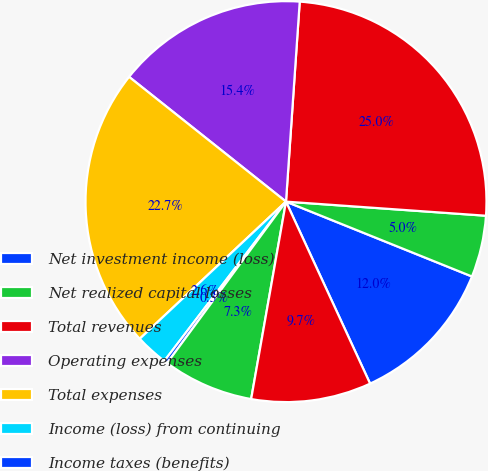<chart> <loc_0><loc_0><loc_500><loc_500><pie_chart><fcel>Net investment income (loss)<fcel>Net realized capital losses<fcel>Total revenues<fcel>Operating expenses<fcel>Total expenses<fcel>Income (loss) from continuing<fcel>Income taxes (benefits)<fcel>Net income<fcel>Net income available to common<nl><fcel>12.02%<fcel>4.97%<fcel>25.03%<fcel>15.4%<fcel>22.68%<fcel>2.63%<fcel>0.28%<fcel>7.32%<fcel>9.67%<nl></chart> 